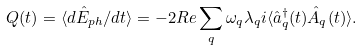Convert formula to latex. <formula><loc_0><loc_0><loc_500><loc_500>Q ( t ) = \langle d \hat { E } _ { p h } / d t \rangle = - 2 { R e } \sum _ { q } \omega _ { q } \lambda _ { q } i \langle \hat { a } _ { q } ^ { \dagger } ( t ) \hat { A } _ { q } ( t ) \rangle .</formula> 